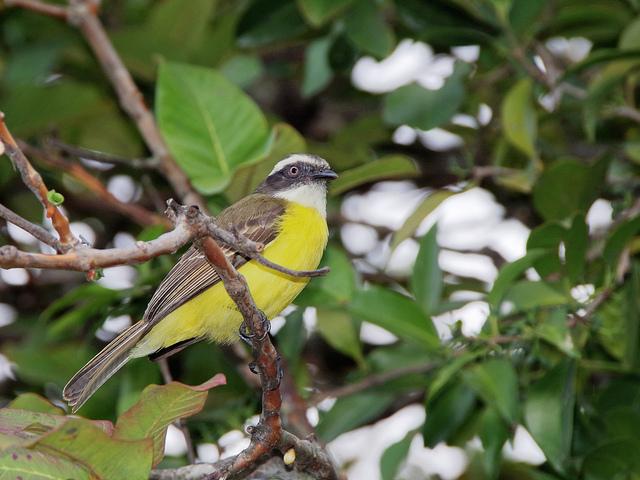What color is the birds breast?
Answer briefly. Yellow. What kind of bird is this?
Write a very short answer. Yellow. What color is the bird?
Answer briefly. Brown and yellow. Is the bird singing?
Short answer required. No. How many birds are there?
Write a very short answer. 1. What does the female of this species look like?
Quick response, please. Less colorful. What color is the bird's neck?
Write a very short answer. White. Is this a finch?
Short answer required. Yes. Is that bird fat?
Write a very short answer. Yes. Is this bird eating?
Answer briefly. No. 